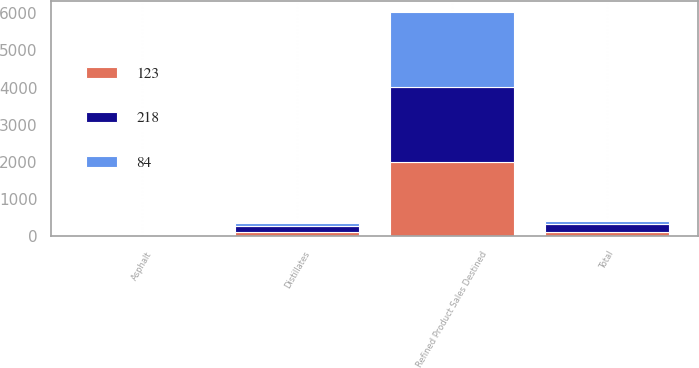<chart> <loc_0><loc_0><loc_500><loc_500><stacked_bar_chart><ecel><fcel>Refined Product Sales Destined<fcel>Distillates<fcel>Asphalt<fcel>Total<nl><fcel>218<fcel>2013<fcel>173<fcel>6<fcel>218<nl><fcel>123<fcel>2012<fcel>114<fcel>8<fcel>123<nl><fcel>84<fcel>2011<fcel>76<fcel>7<fcel>84<nl></chart> 